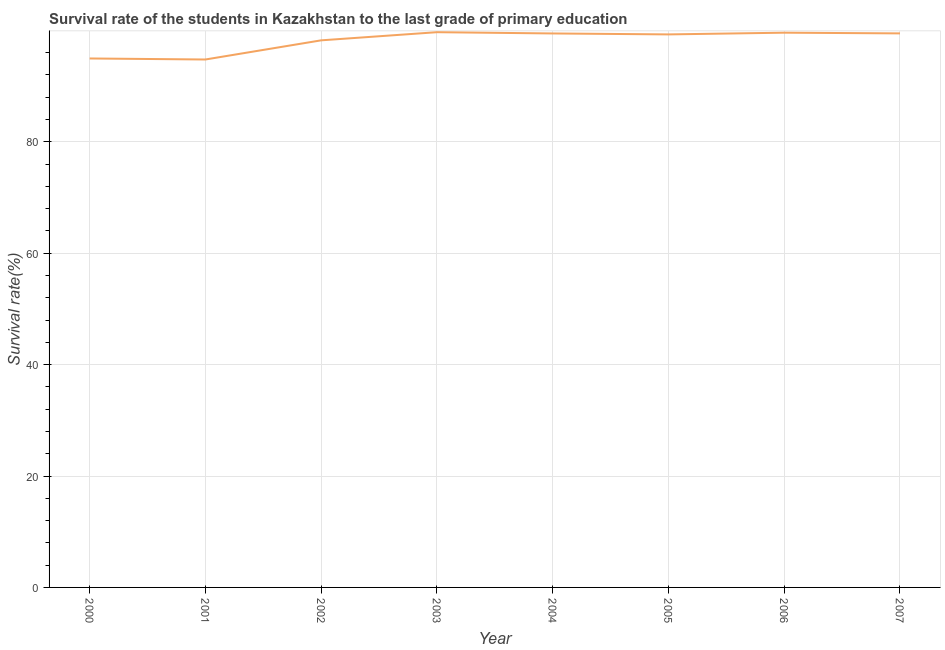What is the survival rate in primary education in 2000?
Offer a very short reply. 94.95. Across all years, what is the maximum survival rate in primary education?
Ensure brevity in your answer.  99.67. Across all years, what is the minimum survival rate in primary education?
Your answer should be compact. 94.77. What is the sum of the survival rate in primary education?
Make the answer very short. 785.34. What is the difference between the survival rate in primary education in 2003 and 2004?
Provide a succinct answer. 0.23. What is the average survival rate in primary education per year?
Keep it short and to the point. 98.17. What is the median survival rate in primary education?
Your answer should be compact. 99.36. Do a majority of the years between 2006 and 2007 (inclusive) have survival rate in primary education greater than 24 %?
Give a very brief answer. Yes. What is the ratio of the survival rate in primary education in 2005 to that in 2007?
Provide a succinct answer. 1. What is the difference between the highest and the second highest survival rate in primary education?
Make the answer very short. 0.09. Is the sum of the survival rate in primary education in 2003 and 2004 greater than the maximum survival rate in primary education across all years?
Keep it short and to the point. Yes. What is the difference between the highest and the lowest survival rate in primary education?
Make the answer very short. 4.9. In how many years, is the survival rate in primary education greater than the average survival rate in primary education taken over all years?
Offer a very short reply. 6. What is the difference between two consecutive major ticks on the Y-axis?
Provide a short and direct response. 20. What is the title of the graph?
Your answer should be compact. Survival rate of the students in Kazakhstan to the last grade of primary education. What is the label or title of the Y-axis?
Give a very brief answer. Survival rate(%). What is the Survival rate(%) in 2000?
Provide a short and direct response. 94.95. What is the Survival rate(%) in 2001?
Your answer should be very brief. 94.77. What is the Survival rate(%) of 2002?
Provide a short and direct response. 98.21. What is the Survival rate(%) in 2003?
Your answer should be compact. 99.67. What is the Survival rate(%) of 2004?
Your response must be concise. 99.44. What is the Survival rate(%) of 2005?
Offer a terse response. 99.27. What is the Survival rate(%) in 2006?
Give a very brief answer. 99.58. What is the Survival rate(%) of 2007?
Offer a terse response. 99.45. What is the difference between the Survival rate(%) in 2000 and 2001?
Your response must be concise. 0.19. What is the difference between the Survival rate(%) in 2000 and 2002?
Your answer should be very brief. -3.25. What is the difference between the Survival rate(%) in 2000 and 2003?
Make the answer very short. -4.72. What is the difference between the Survival rate(%) in 2000 and 2004?
Provide a succinct answer. -4.49. What is the difference between the Survival rate(%) in 2000 and 2005?
Give a very brief answer. -4.32. What is the difference between the Survival rate(%) in 2000 and 2006?
Your answer should be compact. -4.63. What is the difference between the Survival rate(%) in 2000 and 2007?
Your answer should be compact. -4.5. What is the difference between the Survival rate(%) in 2001 and 2002?
Provide a short and direct response. -3.44. What is the difference between the Survival rate(%) in 2001 and 2003?
Offer a terse response. -4.9. What is the difference between the Survival rate(%) in 2001 and 2004?
Your answer should be compact. -4.67. What is the difference between the Survival rate(%) in 2001 and 2005?
Provide a short and direct response. -4.5. What is the difference between the Survival rate(%) in 2001 and 2006?
Keep it short and to the point. -4.81. What is the difference between the Survival rate(%) in 2001 and 2007?
Offer a very short reply. -4.69. What is the difference between the Survival rate(%) in 2002 and 2003?
Provide a short and direct response. -1.46. What is the difference between the Survival rate(%) in 2002 and 2004?
Offer a very short reply. -1.23. What is the difference between the Survival rate(%) in 2002 and 2005?
Provide a succinct answer. -1.06. What is the difference between the Survival rate(%) in 2002 and 2006?
Give a very brief answer. -1.37. What is the difference between the Survival rate(%) in 2002 and 2007?
Give a very brief answer. -1.25. What is the difference between the Survival rate(%) in 2003 and 2004?
Offer a terse response. 0.23. What is the difference between the Survival rate(%) in 2003 and 2005?
Your answer should be compact. 0.4. What is the difference between the Survival rate(%) in 2003 and 2006?
Offer a terse response. 0.09. What is the difference between the Survival rate(%) in 2003 and 2007?
Ensure brevity in your answer.  0.22. What is the difference between the Survival rate(%) in 2004 and 2005?
Offer a terse response. 0.17. What is the difference between the Survival rate(%) in 2004 and 2006?
Offer a very short reply. -0.14. What is the difference between the Survival rate(%) in 2004 and 2007?
Your answer should be compact. -0.01. What is the difference between the Survival rate(%) in 2005 and 2006?
Give a very brief answer. -0.31. What is the difference between the Survival rate(%) in 2005 and 2007?
Offer a very short reply. -0.18. What is the difference between the Survival rate(%) in 2006 and 2007?
Provide a succinct answer. 0.13. What is the ratio of the Survival rate(%) in 2000 to that in 2001?
Offer a very short reply. 1. What is the ratio of the Survival rate(%) in 2000 to that in 2003?
Your answer should be very brief. 0.95. What is the ratio of the Survival rate(%) in 2000 to that in 2004?
Provide a short and direct response. 0.95. What is the ratio of the Survival rate(%) in 2000 to that in 2006?
Provide a short and direct response. 0.95. What is the ratio of the Survival rate(%) in 2000 to that in 2007?
Your answer should be compact. 0.95. What is the ratio of the Survival rate(%) in 2001 to that in 2003?
Offer a terse response. 0.95. What is the ratio of the Survival rate(%) in 2001 to that in 2004?
Your answer should be very brief. 0.95. What is the ratio of the Survival rate(%) in 2001 to that in 2005?
Offer a very short reply. 0.95. What is the ratio of the Survival rate(%) in 2001 to that in 2007?
Provide a short and direct response. 0.95. What is the ratio of the Survival rate(%) in 2002 to that in 2003?
Give a very brief answer. 0.98. What is the ratio of the Survival rate(%) in 2002 to that in 2005?
Provide a short and direct response. 0.99. What is the ratio of the Survival rate(%) in 2003 to that in 2005?
Offer a terse response. 1. What is the ratio of the Survival rate(%) in 2003 to that in 2007?
Offer a terse response. 1. What is the ratio of the Survival rate(%) in 2004 to that in 2006?
Your response must be concise. 1. What is the ratio of the Survival rate(%) in 2005 to that in 2006?
Your answer should be compact. 1. What is the ratio of the Survival rate(%) in 2005 to that in 2007?
Your answer should be compact. 1. 